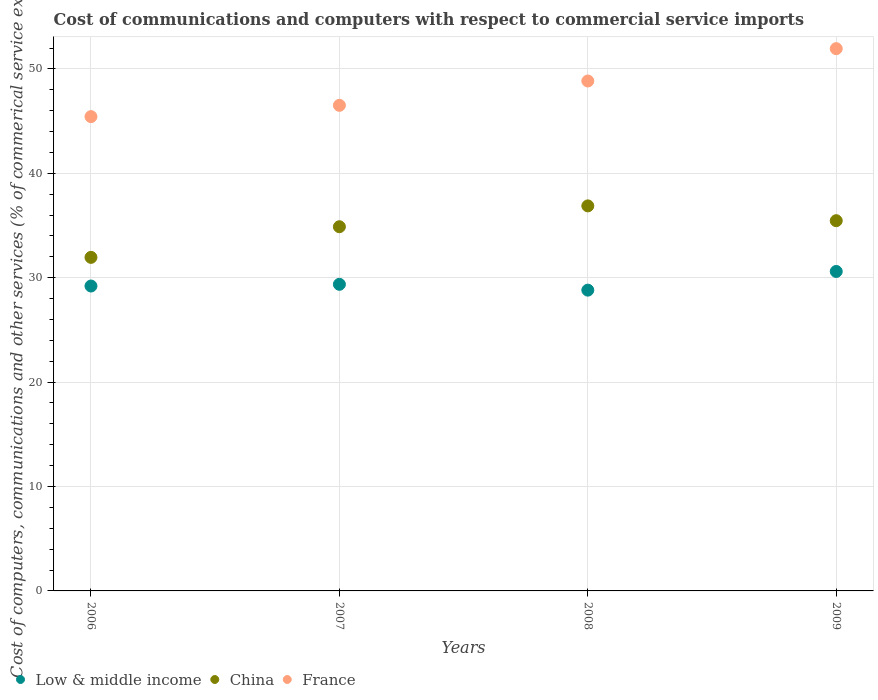Is the number of dotlines equal to the number of legend labels?
Keep it short and to the point. Yes. What is the cost of communications and computers in Low & middle income in 2009?
Ensure brevity in your answer.  30.6. Across all years, what is the maximum cost of communications and computers in Low & middle income?
Keep it short and to the point. 30.6. Across all years, what is the minimum cost of communications and computers in France?
Make the answer very short. 45.43. What is the total cost of communications and computers in Low & middle income in the graph?
Your answer should be compact. 117.97. What is the difference between the cost of communications and computers in France in 2007 and that in 2009?
Offer a terse response. -5.43. What is the difference between the cost of communications and computers in France in 2006 and the cost of communications and computers in Low & middle income in 2007?
Your answer should be very brief. 16.06. What is the average cost of communications and computers in China per year?
Give a very brief answer. 34.79. In the year 2008, what is the difference between the cost of communications and computers in China and cost of communications and computers in Low & middle income?
Your answer should be very brief. 8.07. What is the ratio of the cost of communications and computers in France in 2006 to that in 2007?
Your response must be concise. 0.98. What is the difference between the highest and the second highest cost of communications and computers in Low & middle income?
Your answer should be very brief. 1.23. What is the difference between the highest and the lowest cost of communications and computers in France?
Offer a terse response. 6.51. In how many years, is the cost of communications and computers in China greater than the average cost of communications and computers in China taken over all years?
Provide a succinct answer. 3. Is the sum of the cost of communications and computers in China in 2006 and 2008 greater than the maximum cost of communications and computers in France across all years?
Provide a short and direct response. Yes. Is it the case that in every year, the sum of the cost of communications and computers in China and cost of communications and computers in Low & middle income  is greater than the cost of communications and computers in France?
Your answer should be very brief. Yes. Is the cost of communications and computers in France strictly greater than the cost of communications and computers in China over the years?
Your response must be concise. Yes. How many years are there in the graph?
Your answer should be compact. 4. Does the graph contain any zero values?
Provide a short and direct response. No. Does the graph contain grids?
Offer a very short reply. Yes. How many legend labels are there?
Ensure brevity in your answer.  3. What is the title of the graph?
Give a very brief answer. Cost of communications and computers with respect to commercial service imports. What is the label or title of the Y-axis?
Offer a terse response. Cost of computers, communications and other services (% of commerical service exports). What is the Cost of computers, communications and other services (% of commerical service exports) of Low & middle income in 2006?
Ensure brevity in your answer.  29.2. What is the Cost of computers, communications and other services (% of commerical service exports) in China in 2006?
Your answer should be very brief. 31.95. What is the Cost of computers, communications and other services (% of commerical service exports) of France in 2006?
Ensure brevity in your answer.  45.43. What is the Cost of computers, communications and other services (% of commerical service exports) in Low & middle income in 2007?
Ensure brevity in your answer.  29.37. What is the Cost of computers, communications and other services (% of commerical service exports) in China in 2007?
Your response must be concise. 34.88. What is the Cost of computers, communications and other services (% of commerical service exports) in France in 2007?
Provide a short and direct response. 46.51. What is the Cost of computers, communications and other services (% of commerical service exports) of Low & middle income in 2008?
Provide a short and direct response. 28.81. What is the Cost of computers, communications and other services (% of commerical service exports) of China in 2008?
Make the answer very short. 36.88. What is the Cost of computers, communications and other services (% of commerical service exports) in France in 2008?
Make the answer very short. 48.84. What is the Cost of computers, communications and other services (% of commerical service exports) of Low & middle income in 2009?
Provide a succinct answer. 30.6. What is the Cost of computers, communications and other services (% of commerical service exports) of China in 2009?
Make the answer very short. 35.46. What is the Cost of computers, communications and other services (% of commerical service exports) in France in 2009?
Provide a succinct answer. 51.94. Across all years, what is the maximum Cost of computers, communications and other services (% of commerical service exports) of Low & middle income?
Your response must be concise. 30.6. Across all years, what is the maximum Cost of computers, communications and other services (% of commerical service exports) of China?
Your answer should be very brief. 36.88. Across all years, what is the maximum Cost of computers, communications and other services (% of commerical service exports) in France?
Your answer should be very brief. 51.94. Across all years, what is the minimum Cost of computers, communications and other services (% of commerical service exports) in Low & middle income?
Your answer should be compact. 28.81. Across all years, what is the minimum Cost of computers, communications and other services (% of commerical service exports) of China?
Offer a terse response. 31.95. Across all years, what is the minimum Cost of computers, communications and other services (% of commerical service exports) of France?
Offer a very short reply. 45.43. What is the total Cost of computers, communications and other services (% of commerical service exports) of Low & middle income in the graph?
Your response must be concise. 117.97. What is the total Cost of computers, communications and other services (% of commerical service exports) in China in the graph?
Offer a terse response. 139.17. What is the total Cost of computers, communications and other services (% of commerical service exports) of France in the graph?
Offer a terse response. 192.72. What is the difference between the Cost of computers, communications and other services (% of commerical service exports) in Low & middle income in 2006 and that in 2007?
Provide a succinct answer. -0.16. What is the difference between the Cost of computers, communications and other services (% of commerical service exports) of China in 2006 and that in 2007?
Keep it short and to the point. -2.93. What is the difference between the Cost of computers, communications and other services (% of commerical service exports) of France in 2006 and that in 2007?
Offer a very short reply. -1.08. What is the difference between the Cost of computers, communications and other services (% of commerical service exports) in Low & middle income in 2006 and that in 2008?
Your answer should be very brief. 0.39. What is the difference between the Cost of computers, communications and other services (% of commerical service exports) of China in 2006 and that in 2008?
Your response must be concise. -4.93. What is the difference between the Cost of computers, communications and other services (% of commerical service exports) in France in 2006 and that in 2008?
Provide a short and direct response. -3.41. What is the difference between the Cost of computers, communications and other services (% of commerical service exports) in Low & middle income in 2006 and that in 2009?
Provide a short and direct response. -1.4. What is the difference between the Cost of computers, communications and other services (% of commerical service exports) of China in 2006 and that in 2009?
Your answer should be very brief. -3.51. What is the difference between the Cost of computers, communications and other services (% of commerical service exports) in France in 2006 and that in 2009?
Keep it short and to the point. -6.51. What is the difference between the Cost of computers, communications and other services (% of commerical service exports) of Low & middle income in 2007 and that in 2008?
Offer a very short reply. 0.56. What is the difference between the Cost of computers, communications and other services (% of commerical service exports) in China in 2007 and that in 2008?
Provide a succinct answer. -2. What is the difference between the Cost of computers, communications and other services (% of commerical service exports) in France in 2007 and that in 2008?
Your response must be concise. -2.33. What is the difference between the Cost of computers, communications and other services (% of commerical service exports) in Low & middle income in 2007 and that in 2009?
Provide a short and direct response. -1.23. What is the difference between the Cost of computers, communications and other services (% of commerical service exports) in China in 2007 and that in 2009?
Offer a very short reply. -0.58. What is the difference between the Cost of computers, communications and other services (% of commerical service exports) in France in 2007 and that in 2009?
Offer a very short reply. -5.43. What is the difference between the Cost of computers, communications and other services (% of commerical service exports) of Low & middle income in 2008 and that in 2009?
Provide a succinct answer. -1.79. What is the difference between the Cost of computers, communications and other services (% of commerical service exports) of China in 2008 and that in 2009?
Your response must be concise. 1.42. What is the difference between the Cost of computers, communications and other services (% of commerical service exports) in France in 2008 and that in 2009?
Make the answer very short. -3.1. What is the difference between the Cost of computers, communications and other services (% of commerical service exports) in Low & middle income in 2006 and the Cost of computers, communications and other services (% of commerical service exports) in China in 2007?
Your answer should be very brief. -5.68. What is the difference between the Cost of computers, communications and other services (% of commerical service exports) of Low & middle income in 2006 and the Cost of computers, communications and other services (% of commerical service exports) of France in 2007?
Your answer should be compact. -17.31. What is the difference between the Cost of computers, communications and other services (% of commerical service exports) in China in 2006 and the Cost of computers, communications and other services (% of commerical service exports) in France in 2007?
Offer a terse response. -14.56. What is the difference between the Cost of computers, communications and other services (% of commerical service exports) in Low & middle income in 2006 and the Cost of computers, communications and other services (% of commerical service exports) in China in 2008?
Your response must be concise. -7.68. What is the difference between the Cost of computers, communications and other services (% of commerical service exports) of Low & middle income in 2006 and the Cost of computers, communications and other services (% of commerical service exports) of France in 2008?
Your answer should be very brief. -19.64. What is the difference between the Cost of computers, communications and other services (% of commerical service exports) of China in 2006 and the Cost of computers, communications and other services (% of commerical service exports) of France in 2008?
Offer a very short reply. -16.89. What is the difference between the Cost of computers, communications and other services (% of commerical service exports) in Low & middle income in 2006 and the Cost of computers, communications and other services (% of commerical service exports) in China in 2009?
Your answer should be very brief. -6.26. What is the difference between the Cost of computers, communications and other services (% of commerical service exports) in Low & middle income in 2006 and the Cost of computers, communications and other services (% of commerical service exports) in France in 2009?
Ensure brevity in your answer.  -22.74. What is the difference between the Cost of computers, communications and other services (% of commerical service exports) of China in 2006 and the Cost of computers, communications and other services (% of commerical service exports) of France in 2009?
Make the answer very short. -19.99. What is the difference between the Cost of computers, communications and other services (% of commerical service exports) of Low & middle income in 2007 and the Cost of computers, communications and other services (% of commerical service exports) of China in 2008?
Provide a short and direct response. -7.51. What is the difference between the Cost of computers, communications and other services (% of commerical service exports) in Low & middle income in 2007 and the Cost of computers, communications and other services (% of commerical service exports) in France in 2008?
Ensure brevity in your answer.  -19.47. What is the difference between the Cost of computers, communications and other services (% of commerical service exports) in China in 2007 and the Cost of computers, communications and other services (% of commerical service exports) in France in 2008?
Ensure brevity in your answer.  -13.96. What is the difference between the Cost of computers, communications and other services (% of commerical service exports) of Low & middle income in 2007 and the Cost of computers, communications and other services (% of commerical service exports) of China in 2009?
Your response must be concise. -6.09. What is the difference between the Cost of computers, communications and other services (% of commerical service exports) of Low & middle income in 2007 and the Cost of computers, communications and other services (% of commerical service exports) of France in 2009?
Provide a short and direct response. -22.57. What is the difference between the Cost of computers, communications and other services (% of commerical service exports) in China in 2007 and the Cost of computers, communications and other services (% of commerical service exports) in France in 2009?
Keep it short and to the point. -17.06. What is the difference between the Cost of computers, communications and other services (% of commerical service exports) of Low & middle income in 2008 and the Cost of computers, communications and other services (% of commerical service exports) of China in 2009?
Ensure brevity in your answer.  -6.65. What is the difference between the Cost of computers, communications and other services (% of commerical service exports) in Low & middle income in 2008 and the Cost of computers, communications and other services (% of commerical service exports) in France in 2009?
Offer a terse response. -23.13. What is the difference between the Cost of computers, communications and other services (% of commerical service exports) of China in 2008 and the Cost of computers, communications and other services (% of commerical service exports) of France in 2009?
Ensure brevity in your answer.  -15.06. What is the average Cost of computers, communications and other services (% of commerical service exports) in Low & middle income per year?
Your answer should be compact. 29.49. What is the average Cost of computers, communications and other services (% of commerical service exports) in China per year?
Make the answer very short. 34.79. What is the average Cost of computers, communications and other services (% of commerical service exports) in France per year?
Keep it short and to the point. 48.18. In the year 2006, what is the difference between the Cost of computers, communications and other services (% of commerical service exports) of Low & middle income and Cost of computers, communications and other services (% of commerical service exports) of China?
Provide a succinct answer. -2.75. In the year 2006, what is the difference between the Cost of computers, communications and other services (% of commerical service exports) of Low & middle income and Cost of computers, communications and other services (% of commerical service exports) of France?
Ensure brevity in your answer.  -16.23. In the year 2006, what is the difference between the Cost of computers, communications and other services (% of commerical service exports) in China and Cost of computers, communications and other services (% of commerical service exports) in France?
Your answer should be compact. -13.48. In the year 2007, what is the difference between the Cost of computers, communications and other services (% of commerical service exports) in Low & middle income and Cost of computers, communications and other services (% of commerical service exports) in China?
Your response must be concise. -5.52. In the year 2007, what is the difference between the Cost of computers, communications and other services (% of commerical service exports) of Low & middle income and Cost of computers, communications and other services (% of commerical service exports) of France?
Offer a terse response. -17.14. In the year 2007, what is the difference between the Cost of computers, communications and other services (% of commerical service exports) of China and Cost of computers, communications and other services (% of commerical service exports) of France?
Keep it short and to the point. -11.63. In the year 2008, what is the difference between the Cost of computers, communications and other services (% of commerical service exports) in Low & middle income and Cost of computers, communications and other services (% of commerical service exports) in China?
Offer a terse response. -8.07. In the year 2008, what is the difference between the Cost of computers, communications and other services (% of commerical service exports) in Low & middle income and Cost of computers, communications and other services (% of commerical service exports) in France?
Provide a short and direct response. -20.03. In the year 2008, what is the difference between the Cost of computers, communications and other services (% of commerical service exports) of China and Cost of computers, communications and other services (% of commerical service exports) of France?
Offer a very short reply. -11.96. In the year 2009, what is the difference between the Cost of computers, communications and other services (% of commerical service exports) of Low & middle income and Cost of computers, communications and other services (% of commerical service exports) of China?
Ensure brevity in your answer.  -4.86. In the year 2009, what is the difference between the Cost of computers, communications and other services (% of commerical service exports) in Low & middle income and Cost of computers, communications and other services (% of commerical service exports) in France?
Provide a short and direct response. -21.34. In the year 2009, what is the difference between the Cost of computers, communications and other services (% of commerical service exports) of China and Cost of computers, communications and other services (% of commerical service exports) of France?
Ensure brevity in your answer.  -16.48. What is the ratio of the Cost of computers, communications and other services (% of commerical service exports) of Low & middle income in 2006 to that in 2007?
Give a very brief answer. 0.99. What is the ratio of the Cost of computers, communications and other services (% of commerical service exports) in China in 2006 to that in 2007?
Offer a terse response. 0.92. What is the ratio of the Cost of computers, communications and other services (% of commerical service exports) in France in 2006 to that in 2007?
Ensure brevity in your answer.  0.98. What is the ratio of the Cost of computers, communications and other services (% of commerical service exports) in Low & middle income in 2006 to that in 2008?
Your answer should be very brief. 1.01. What is the ratio of the Cost of computers, communications and other services (% of commerical service exports) in China in 2006 to that in 2008?
Give a very brief answer. 0.87. What is the ratio of the Cost of computers, communications and other services (% of commerical service exports) of France in 2006 to that in 2008?
Make the answer very short. 0.93. What is the ratio of the Cost of computers, communications and other services (% of commerical service exports) in Low & middle income in 2006 to that in 2009?
Offer a very short reply. 0.95. What is the ratio of the Cost of computers, communications and other services (% of commerical service exports) of China in 2006 to that in 2009?
Ensure brevity in your answer.  0.9. What is the ratio of the Cost of computers, communications and other services (% of commerical service exports) in France in 2006 to that in 2009?
Keep it short and to the point. 0.87. What is the ratio of the Cost of computers, communications and other services (% of commerical service exports) of Low & middle income in 2007 to that in 2008?
Provide a short and direct response. 1.02. What is the ratio of the Cost of computers, communications and other services (% of commerical service exports) of China in 2007 to that in 2008?
Provide a short and direct response. 0.95. What is the ratio of the Cost of computers, communications and other services (% of commerical service exports) in France in 2007 to that in 2008?
Your answer should be very brief. 0.95. What is the ratio of the Cost of computers, communications and other services (% of commerical service exports) of Low & middle income in 2007 to that in 2009?
Keep it short and to the point. 0.96. What is the ratio of the Cost of computers, communications and other services (% of commerical service exports) of China in 2007 to that in 2009?
Ensure brevity in your answer.  0.98. What is the ratio of the Cost of computers, communications and other services (% of commerical service exports) of France in 2007 to that in 2009?
Offer a terse response. 0.9. What is the ratio of the Cost of computers, communications and other services (% of commerical service exports) in Low & middle income in 2008 to that in 2009?
Give a very brief answer. 0.94. What is the ratio of the Cost of computers, communications and other services (% of commerical service exports) in China in 2008 to that in 2009?
Your answer should be very brief. 1.04. What is the ratio of the Cost of computers, communications and other services (% of commerical service exports) of France in 2008 to that in 2009?
Provide a succinct answer. 0.94. What is the difference between the highest and the second highest Cost of computers, communications and other services (% of commerical service exports) in Low & middle income?
Your answer should be compact. 1.23. What is the difference between the highest and the second highest Cost of computers, communications and other services (% of commerical service exports) of China?
Ensure brevity in your answer.  1.42. What is the difference between the highest and the second highest Cost of computers, communications and other services (% of commerical service exports) of France?
Offer a very short reply. 3.1. What is the difference between the highest and the lowest Cost of computers, communications and other services (% of commerical service exports) in Low & middle income?
Keep it short and to the point. 1.79. What is the difference between the highest and the lowest Cost of computers, communications and other services (% of commerical service exports) of China?
Give a very brief answer. 4.93. What is the difference between the highest and the lowest Cost of computers, communications and other services (% of commerical service exports) of France?
Offer a terse response. 6.51. 